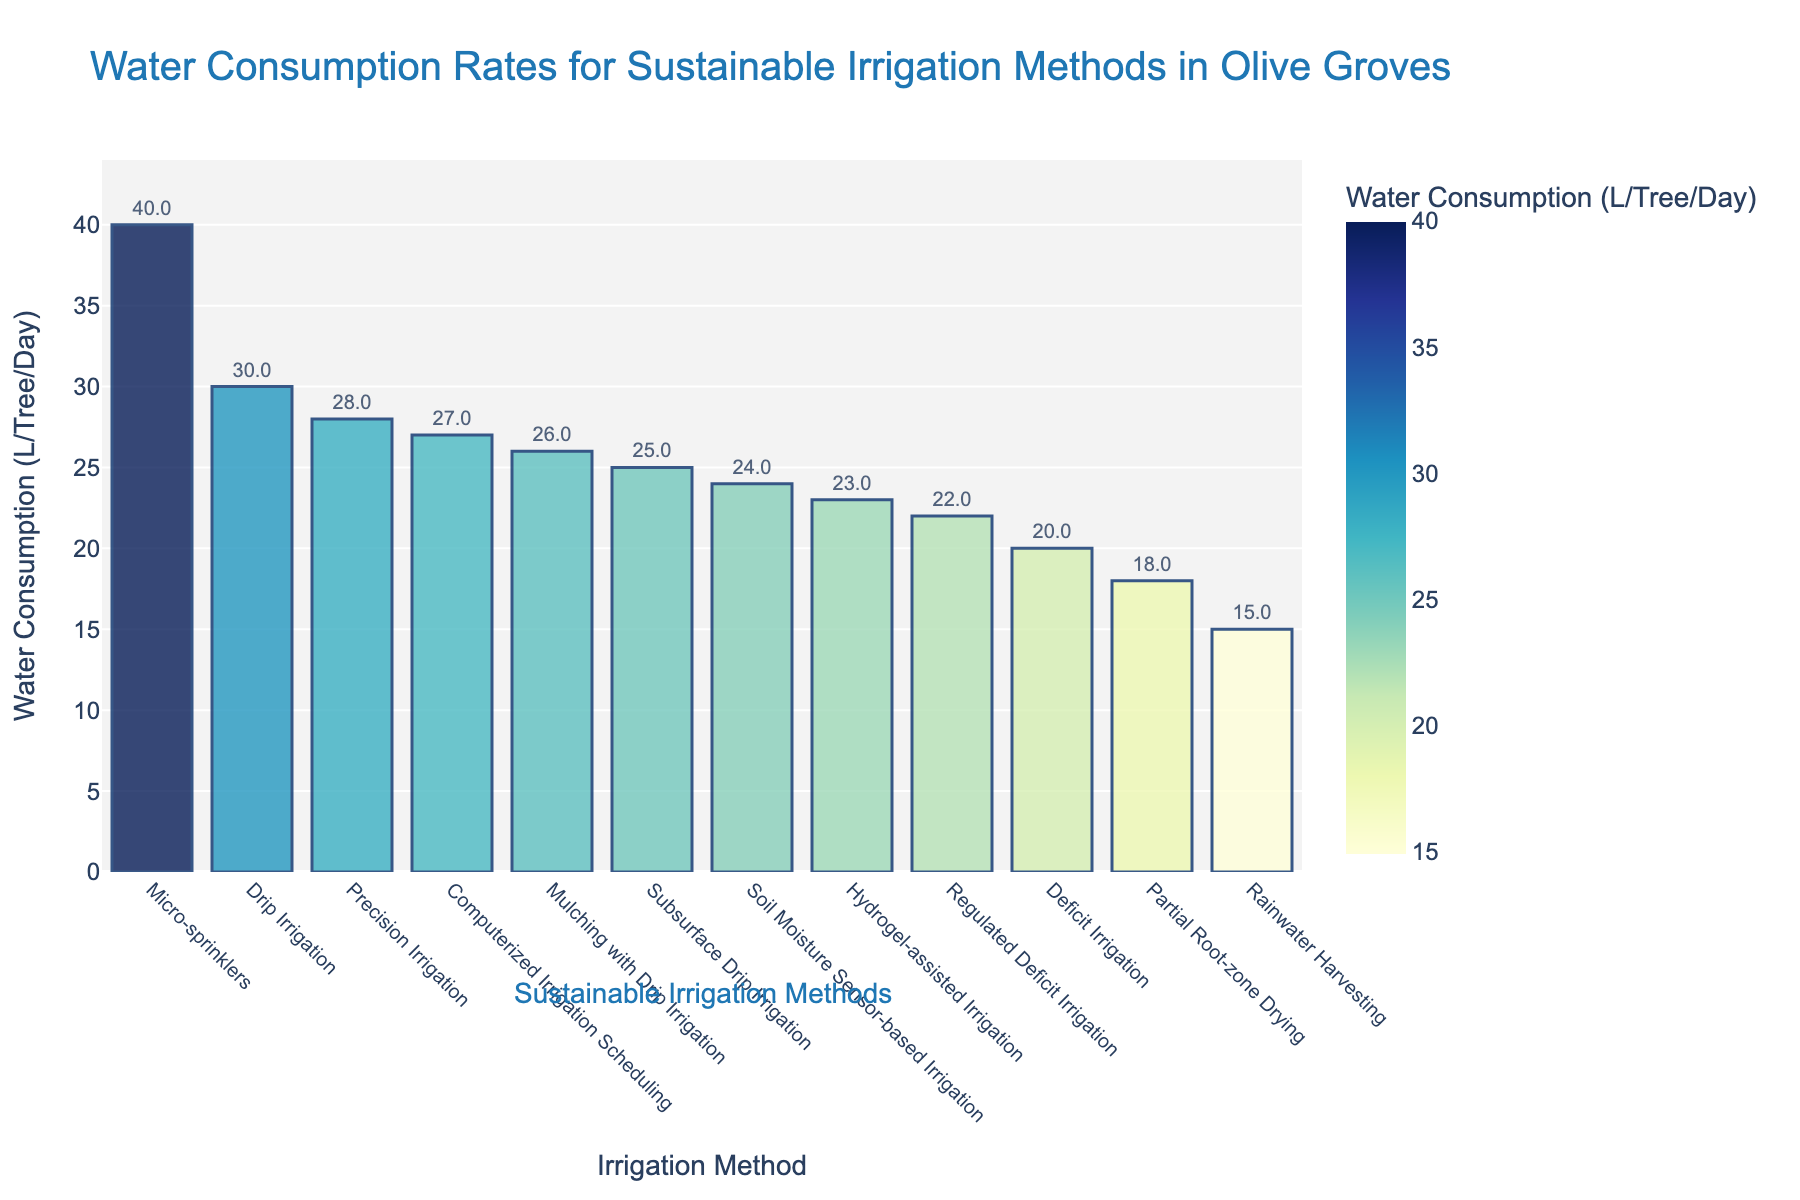What's the irrigation method with the highest water consumption rate? The heights of the bars in the figure represent the water consumption rates. The highest bar corresponds to the method with the highest water consumption.
Answer: Micro-sprinklers Which irrigation method consumes less water: Deficit Irrigation or Precision Irrigation? Compare the heights of the bars for Deficit Irrigation and Precision Irrigation. The shorter bar indicates the method that consumes less water.
Answer: Deficit Irrigation What is the difference in water consumption between Drip Irrigation and Subsurface Drip Irrigation? Subtract the water consumption value of Subsurface Drip Irrigation from that of Drip Irrigation: 30 - 25 = 5 liters/tree/day.
Answer: 5 liters/tree/day How many irrigation methods have a water consumption rate less than 25 liters/tree/day? Count the number of bars with a height lower than the 25 liters/tree/day mark. The bars correspond to Partial Root-zone Drying, Rainwater Harvesting, Soil Moisture Sensor-based Irrigation, Regulated Deficit Irrigation, Deficit Irrigation, and Hydrogel-assisted Irrigation.
Answer: 6 methods What's the average water consumption rate for the listed irrigation methods? Sum the water consumption rates and divide by the number of methods. Total consumption = (30+25+40+20+22+18+28+26+15+23+27+24). Number of methods = 12. Average = (30+25+40+20+22+18+28+26+15+23+27+24)/12 = 298/12 ≈ 24.83 liters/tree/day
Answer: 24.83 liters/tree/day Which irrigation method falls in the middle range of water consumption rates when the methods are sorted? Sort the methods by water consumption rate. The method in the middle of the list (6th method) is Subsurface Drip Irrigation.
Answer: Subsurface Drip Irrigation Are the water consumption rates for Computerized Irrigation Scheduling and Soil Moisture Sensor-based Irrigation very different? Compare the heights of the bars for both methods. Computerized Irrigation Scheduling has 27 liters/tree/day and Soil Moisture Sensor-based Irrigation has 24 liters/tree/day. The difference is 3 liters/tree/day.
Answer: No, difference is 3 liters/tree/day 